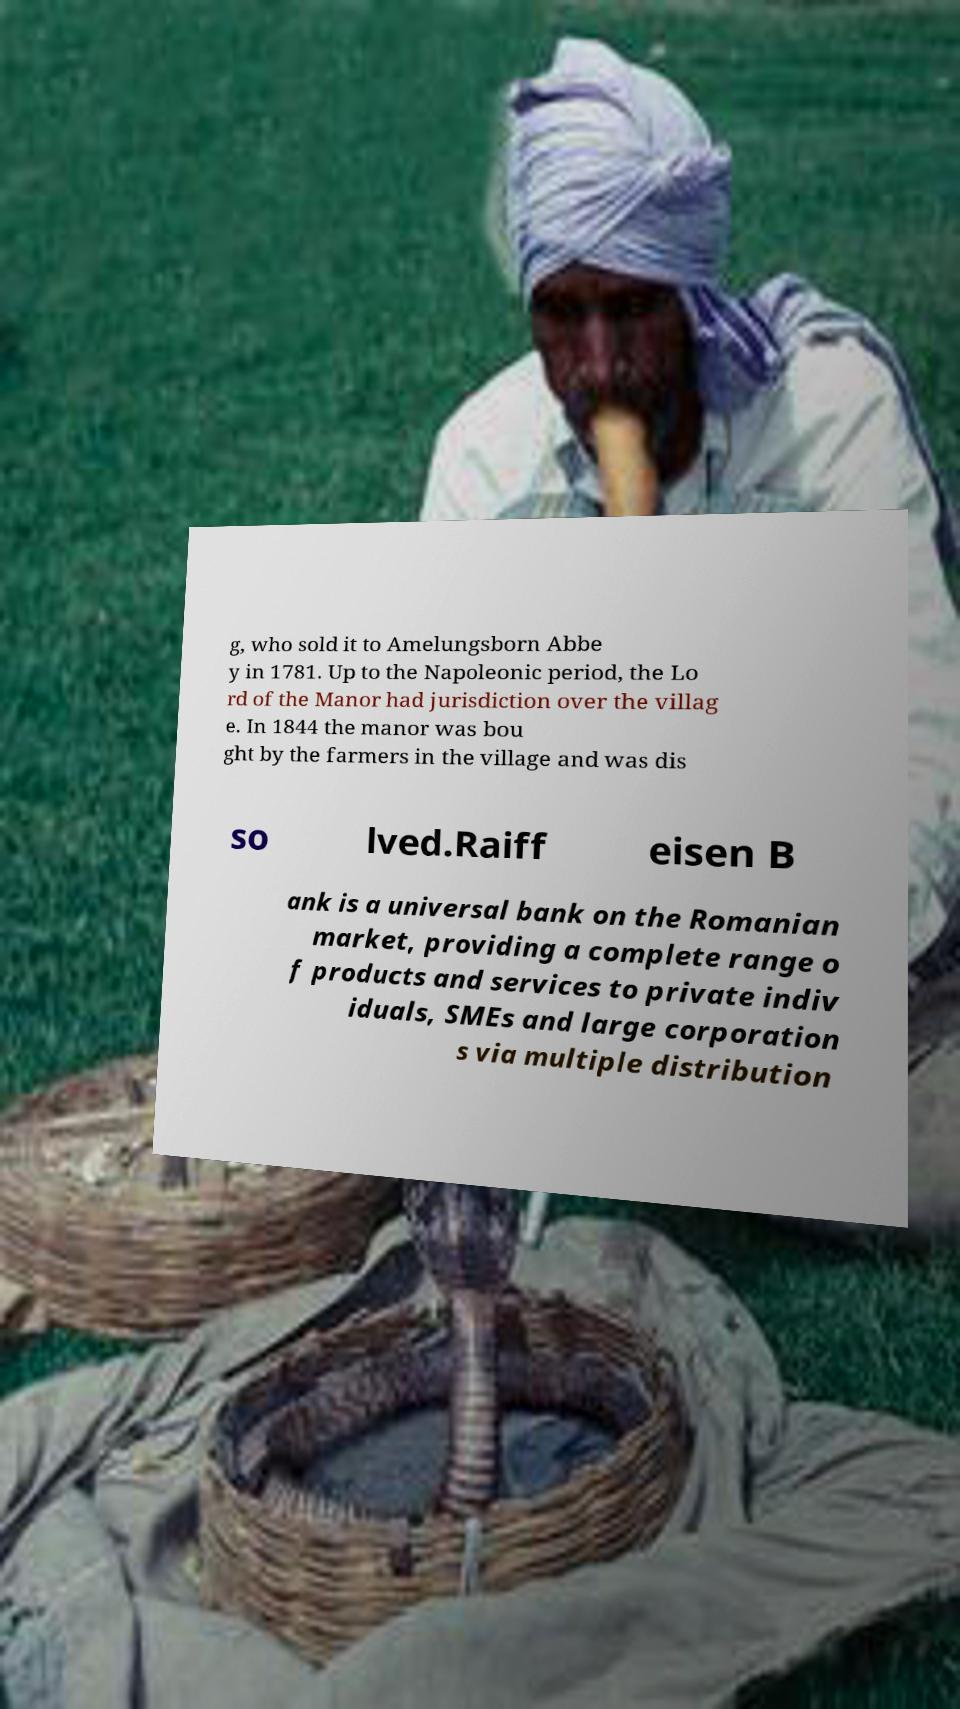What messages or text are displayed in this image? I need them in a readable, typed format. g, who sold it to Amelungsborn Abbe y in 1781. Up to the Napoleonic period, the Lo rd of the Manor had jurisdiction over the villag e. In 1844 the manor was bou ght by the farmers in the village and was dis so lved.Raiff eisen B ank is a universal bank on the Romanian market, providing a complete range o f products and services to private indiv iduals, SMEs and large corporation s via multiple distribution 